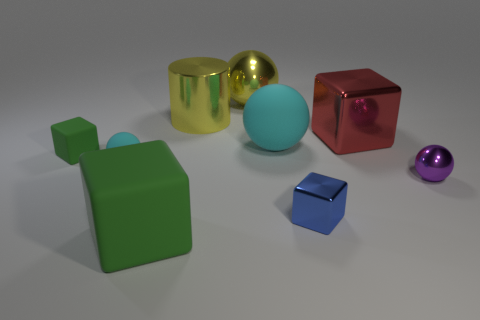How many green blocks must be subtracted to get 1 green blocks? 1 Subtract 0 green spheres. How many objects are left? 9 Subtract all spheres. How many objects are left? 5 Subtract 3 cubes. How many cubes are left? 1 Subtract all yellow cubes. Subtract all red spheres. How many cubes are left? 4 Subtract all cyan blocks. How many green cylinders are left? 0 Subtract all large green objects. Subtract all cylinders. How many objects are left? 7 Add 1 metallic objects. How many metallic objects are left? 6 Add 9 tiny purple spheres. How many tiny purple spheres exist? 10 Add 1 small metallic objects. How many objects exist? 10 